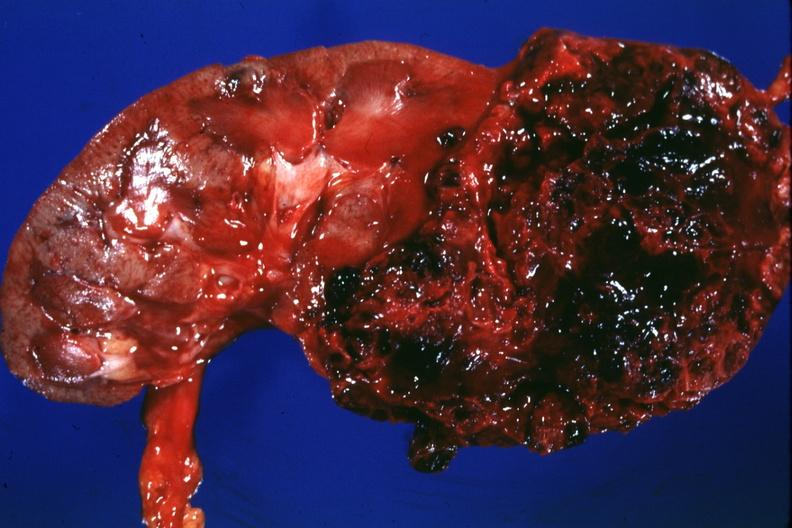does molluscum contagiosum show large lesion more hemorrhagic than usual -?
Answer the question using a single word or phrase. No 